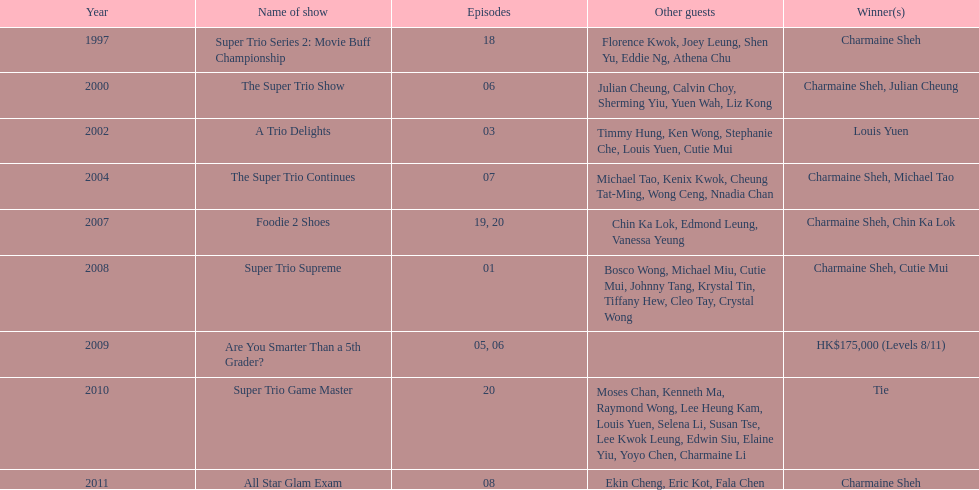How many instances has charmaine sheh been victorious on a variety show? 6. 